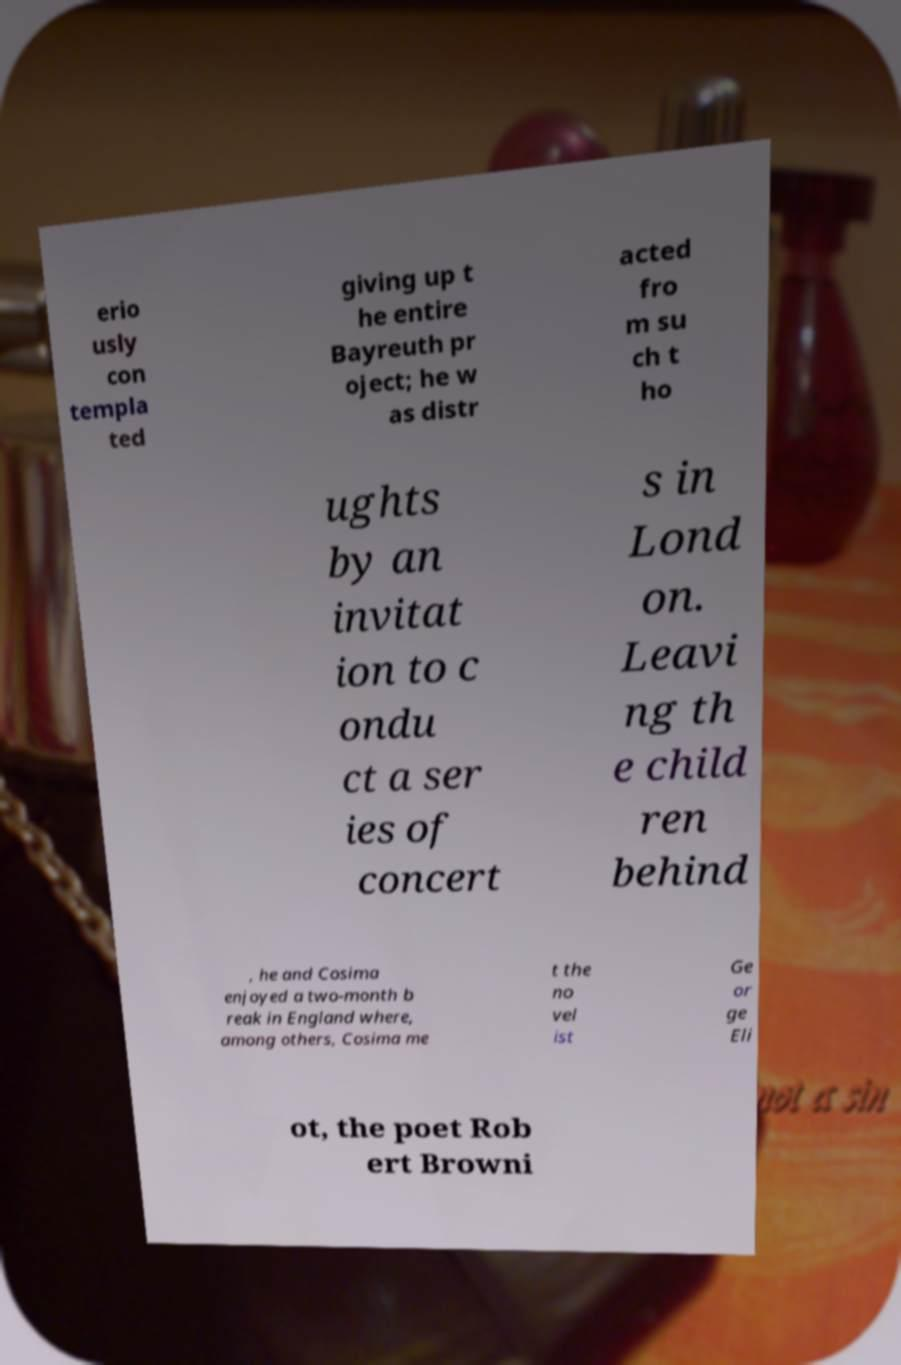Please identify and transcribe the text found in this image. erio usly con templa ted giving up t he entire Bayreuth pr oject; he w as distr acted fro m su ch t ho ughts by an invitat ion to c ondu ct a ser ies of concert s in Lond on. Leavi ng th e child ren behind , he and Cosima enjoyed a two-month b reak in England where, among others, Cosima me t the no vel ist Ge or ge Eli ot, the poet Rob ert Browni 